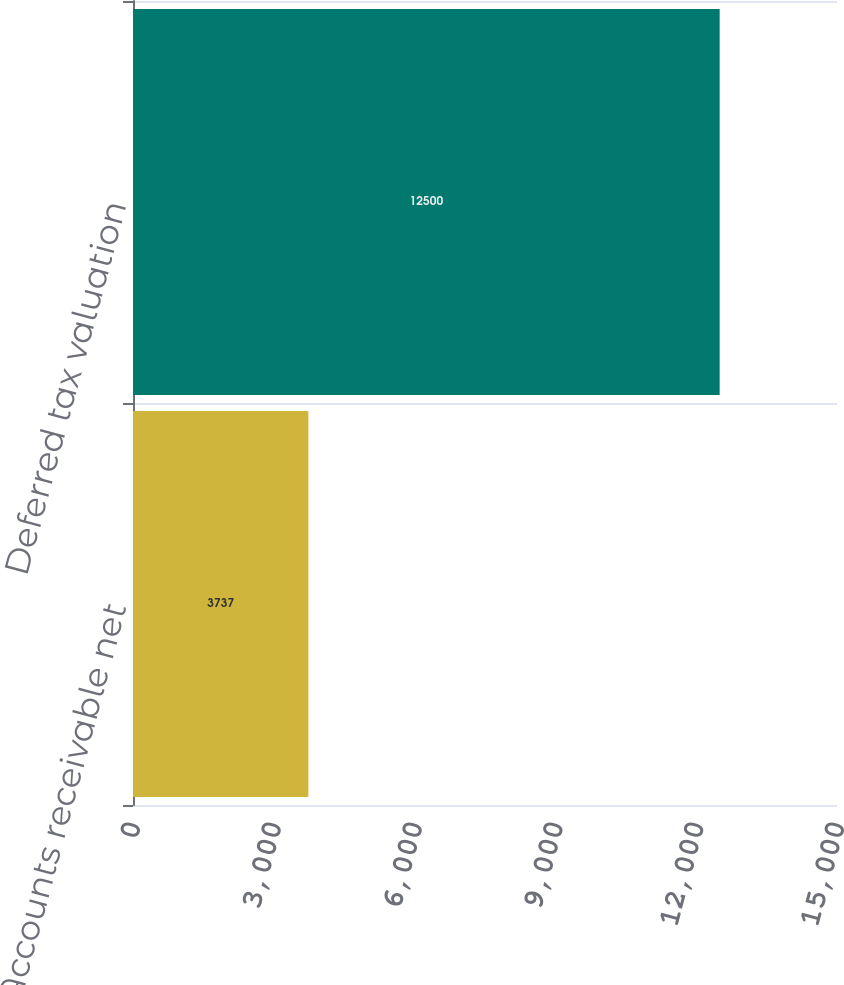<chart> <loc_0><loc_0><loc_500><loc_500><bar_chart><fcel>Accounts receivable net<fcel>Deferred tax valuation<nl><fcel>3737<fcel>12500<nl></chart> 